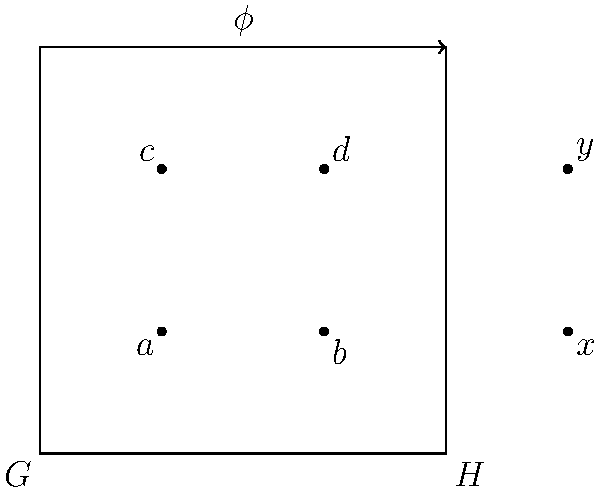In the diagram above, $\phi$ represents a group homomorphism from group $G$ to group $H$. If $\phi(a) = \phi(b) = x$ and $\phi(c) = \phi(d) = y$, what can we conclude about the kernel of $\phi$? Explain your reasoning using the properties of group homomorphisms. Let's approach this step-by-step:

1) Recall that the kernel of a group homomorphism $\phi: G \rightarrow H$ is defined as:
   $\text{ker}(\phi) = \{g \in G : \phi(g) = e_H\}$, where $e_H$ is the identity element of $H$.

2) From the given information, we can see that:
   $\phi(a) = \phi(b) = x$ and $\phi(c) = \phi(d) = y$

3) A key property of group homomorphisms is that they preserve the group operation. This means:
   $\phi(g_1 \cdot g_2) = \phi(g_1) \cdot \phi(g_2)$ for any $g_1, g_2 \in G$

4) Consider the element $a^{-1}b$ in $G$. Applying $\phi$ to this:
   $\phi(a^{-1}b) = \phi(a^{-1}) \cdot \phi(b) = \phi(a)^{-1} \cdot \phi(b) = x^{-1} \cdot x = e_H$

5) Similarly, $\phi(c^{-1}d) = y^{-1} \cdot y = e_H$

6) This means that both $a^{-1}b$ and $c^{-1}d$ are in the kernel of $\phi$.

7) The kernel is always a normal subgroup of $G$, and it contains at least these two non-identity elements.

Therefore, we can conclude that the kernel of $\phi$ is non-trivial (contains elements other than the identity) and has at least four elements: $e_G$, $a^{-1}b$, $c^{-1}d$, and $(a^{-1}b) \cdot (c^{-1}d)$.
Answer: The kernel of $\phi$ is non-trivial and contains at least four elements. 